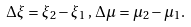Convert formula to latex. <formula><loc_0><loc_0><loc_500><loc_500>\Delta \xi = \xi _ { 2 } - \xi _ { 1 } \, , \, \Delta \mu = \mu _ { 2 } - \mu _ { 1 } .</formula> 